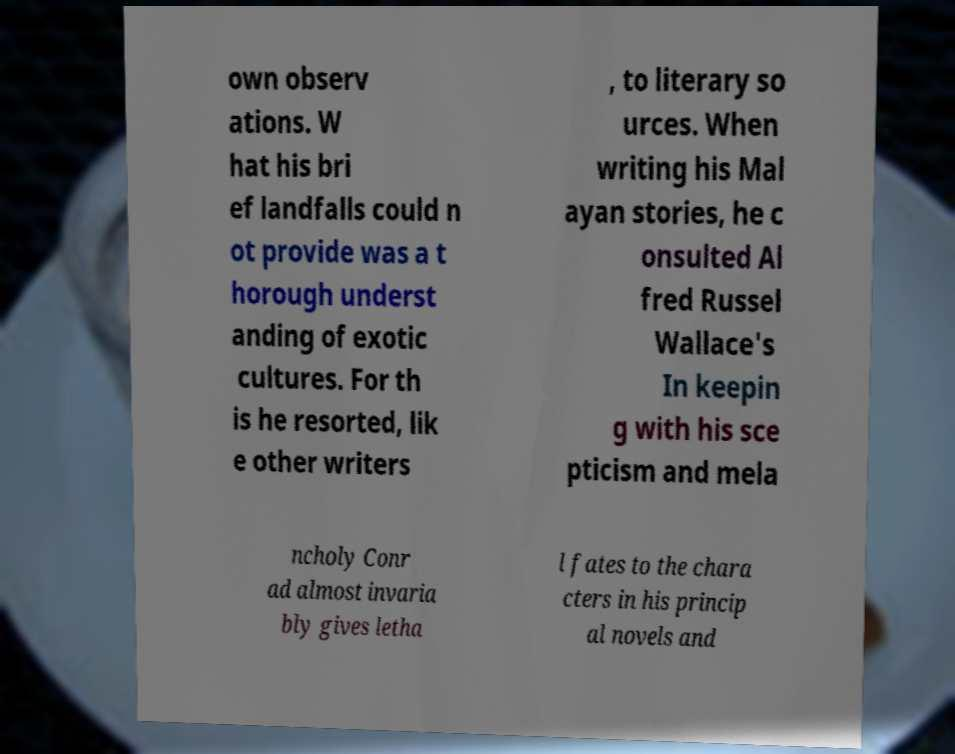Can you accurately transcribe the text from the provided image for me? own observ ations. W hat his bri ef landfalls could n ot provide was a t horough underst anding of exotic cultures. For th is he resorted, lik e other writers , to literary so urces. When writing his Mal ayan stories, he c onsulted Al fred Russel Wallace's In keepin g with his sce pticism and mela ncholy Conr ad almost invaria bly gives letha l fates to the chara cters in his princip al novels and 